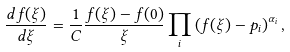Convert formula to latex. <formula><loc_0><loc_0><loc_500><loc_500>\frac { d f ( \xi ) } { d \xi } = \frac { 1 } { C } \frac { f ( \xi ) - f ( 0 ) } { \xi } \prod _ { i } \left ( f ( \xi ) - p _ { i } \right ) ^ { \alpha _ { i } } ,</formula> 